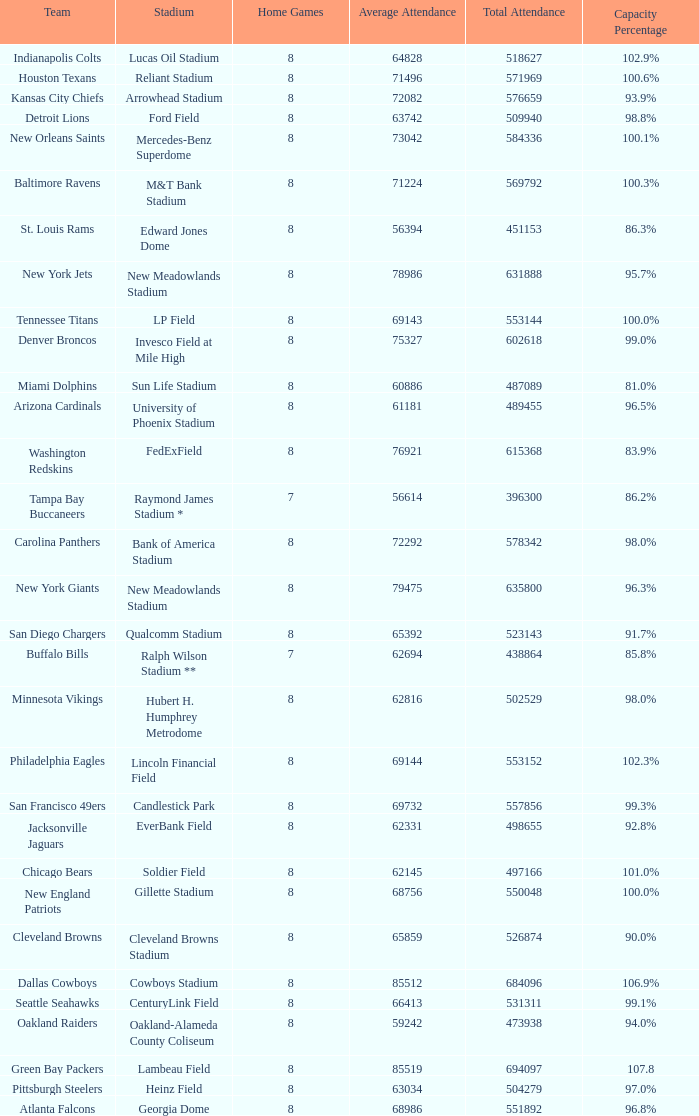How many average attendance has a capacity percentage of 96.5% 1.0. 